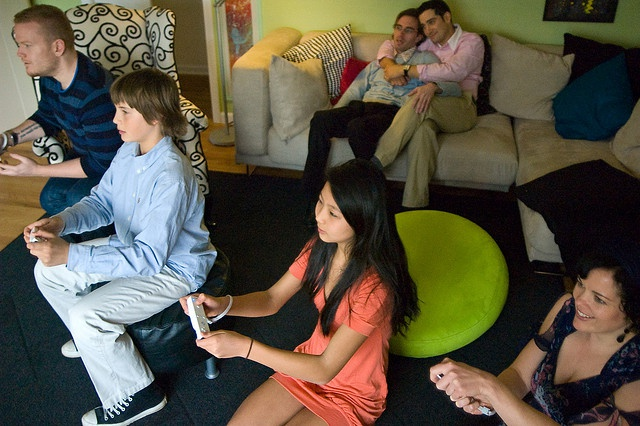Describe the objects in this image and their specific colors. I can see people in gray, lightblue, and black tones, people in gray, black, salmon, and tan tones, people in gray, black, tan, and maroon tones, couch in gray, tan, and olive tones, and couch in gray and black tones in this image. 